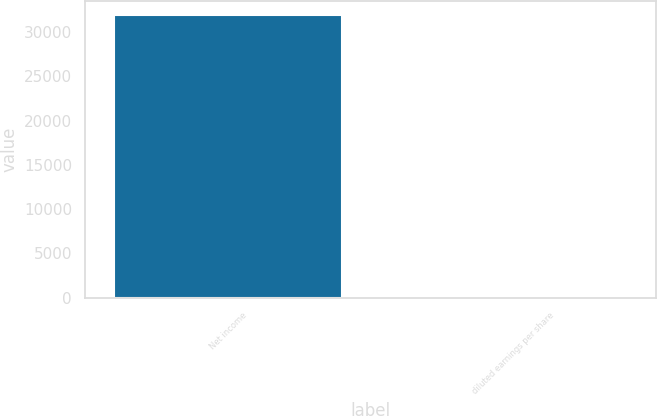Convert chart to OTSL. <chart><loc_0><loc_0><loc_500><loc_500><bar_chart><fcel>Net income<fcel>diluted earnings per share<nl><fcel>31962<fcel>0.44<nl></chart> 